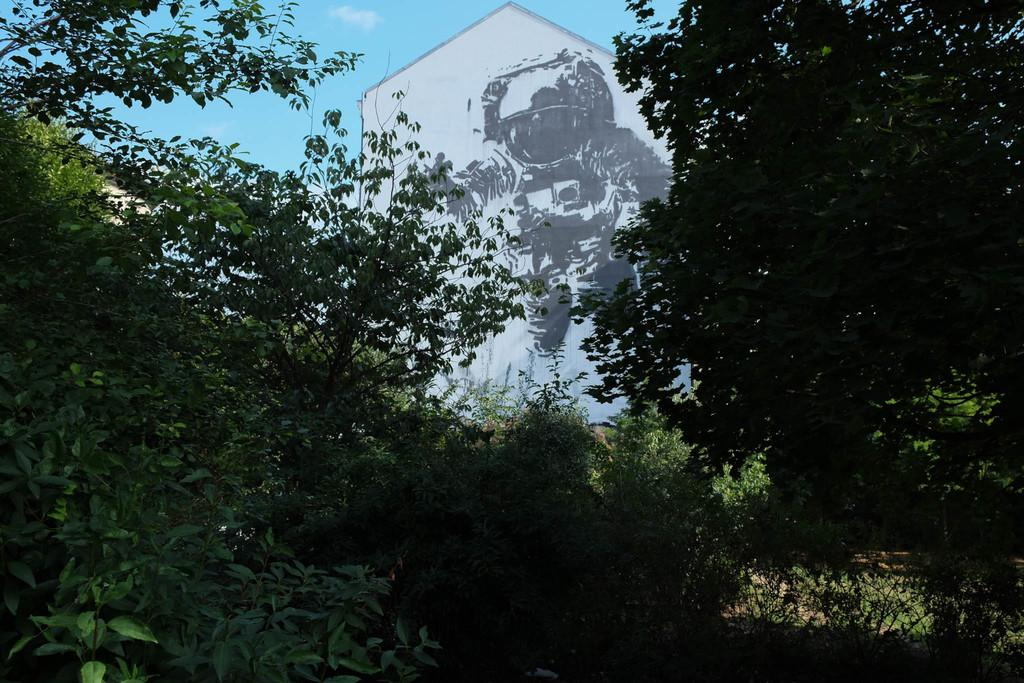What type of vegetation can be seen in the image? There are trees in the image. What is on the wall in the background? There is a painting on the wall in the background. What can be seen in the sky in the image? The sky is visible in the background, and clouds are present. What type of banana is being used to paint the wall in the image? There is no banana present in the image, and it is a painting on the wall, not a banana being used to paint. How many eggs are visible in the sky in the image? There are no eggs visible in the sky in the image; only clouds are present. 